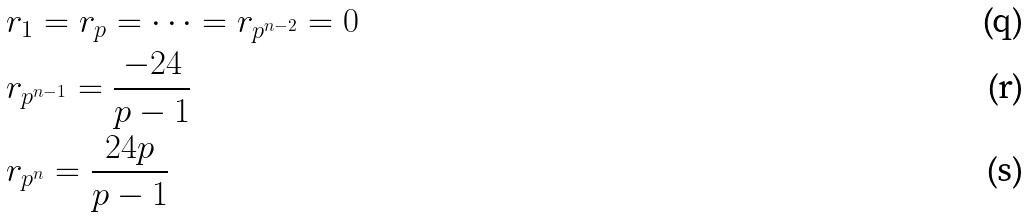Convert formula to latex. <formula><loc_0><loc_0><loc_500><loc_500>& r _ { 1 } = r _ { p } = \dots = r _ { p ^ { n - 2 } } = 0 \\ & r _ { p ^ { n - 1 } } = \frac { - 2 4 } { p - 1 } \\ & r _ { p ^ { n } } = \frac { 2 4 p } { p - 1 }</formula> 